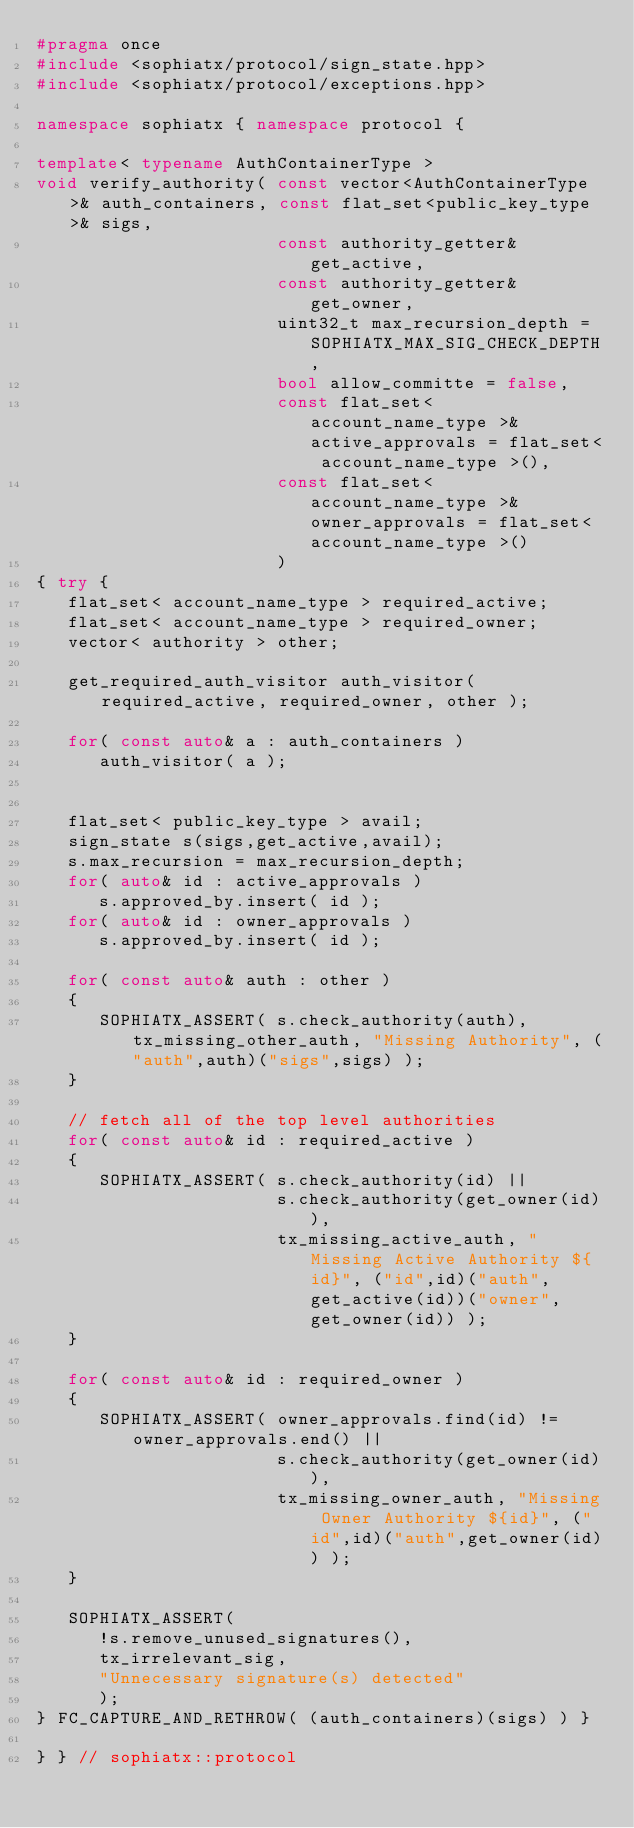<code> <loc_0><loc_0><loc_500><loc_500><_C++_>#pragma once
#include <sophiatx/protocol/sign_state.hpp>
#include <sophiatx/protocol/exceptions.hpp>

namespace sophiatx { namespace protocol {

template< typename AuthContainerType >
void verify_authority( const vector<AuthContainerType>& auth_containers, const flat_set<public_key_type>& sigs,
                       const authority_getter& get_active,
                       const authority_getter& get_owner,
                       uint32_t max_recursion_depth = SOPHIATX_MAX_SIG_CHECK_DEPTH,
                       bool allow_committe = false,
                       const flat_set< account_name_type >& active_approvals = flat_set< account_name_type >(),
                       const flat_set< account_name_type >& owner_approvals = flat_set< account_name_type >()
                       )
{ try {
   flat_set< account_name_type > required_active;
   flat_set< account_name_type > required_owner;
   vector< authority > other;

   get_required_auth_visitor auth_visitor( required_active, required_owner, other );

   for( const auto& a : auth_containers )
      auth_visitor( a );


   flat_set< public_key_type > avail;
   sign_state s(sigs,get_active,avail);
   s.max_recursion = max_recursion_depth;
   for( auto& id : active_approvals )
      s.approved_by.insert( id );
   for( auto& id : owner_approvals )
      s.approved_by.insert( id );

   for( const auto& auth : other )
   {
      SOPHIATX_ASSERT( s.check_authority(auth), tx_missing_other_auth, "Missing Authority", ("auth",auth)("sigs",sigs) );
   }

   // fetch all of the top level authorities
   for( const auto& id : required_active )
   {
      SOPHIATX_ASSERT( s.check_authority(id) ||
                       s.check_authority(get_owner(id)),
                       tx_missing_active_auth, "Missing Active Authority ${id}", ("id",id)("auth",get_active(id))("owner",get_owner(id)) );
   }

   for( const auto& id : required_owner )
   {
      SOPHIATX_ASSERT( owner_approvals.find(id) != owner_approvals.end() ||
                       s.check_authority(get_owner(id)),
                       tx_missing_owner_auth, "Missing Owner Authority ${id}", ("id",id)("auth",get_owner(id)) );
   }

   SOPHIATX_ASSERT(
      !s.remove_unused_signatures(),
      tx_irrelevant_sig,
      "Unnecessary signature(s) detected"
      );
} FC_CAPTURE_AND_RETHROW( (auth_containers)(sigs) ) }

} } // sophiatx::protocol
</code> 